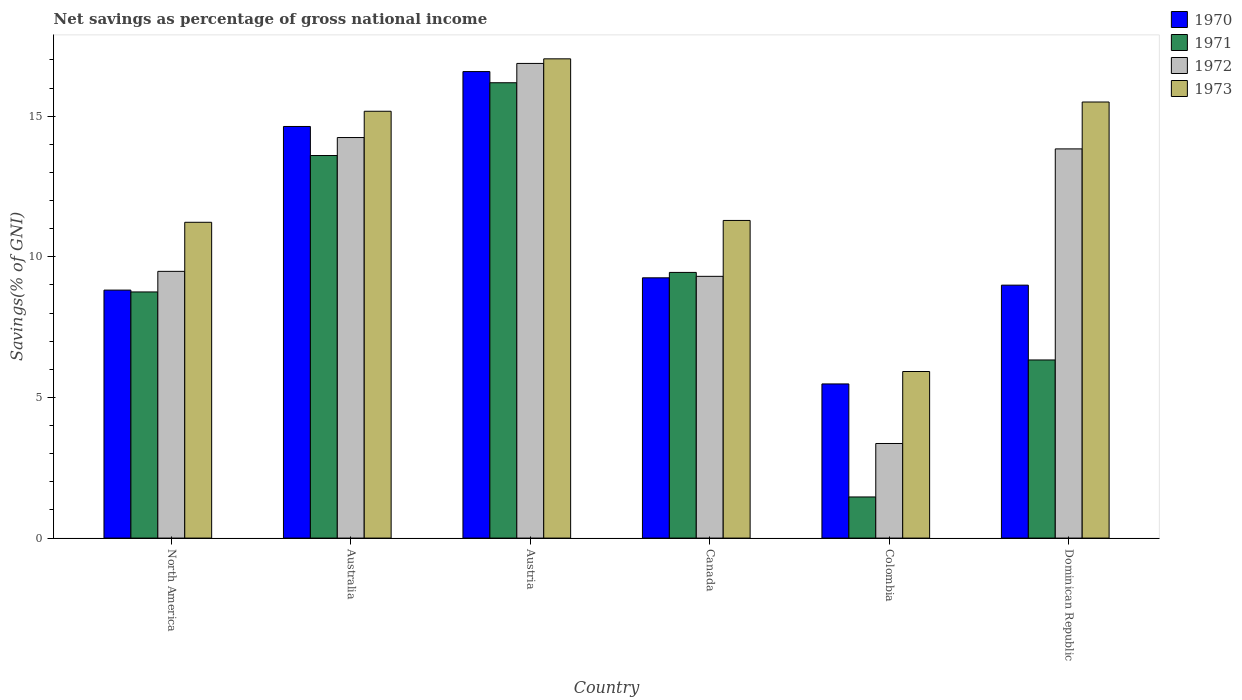How many groups of bars are there?
Offer a terse response. 6. Are the number of bars per tick equal to the number of legend labels?
Provide a short and direct response. Yes. How many bars are there on the 1st tick from the left?
Provide a short and direct response. 4. What is the label of the 3rd group of bars from the left?
Provide a short and direct response. Austria. In how many cases, is the number of bars for a given country not equal to the number of legend labels?
Keep it short and to the point. 0. What is the total savings in 1970 in Austria?
Your answer should be very brief. 16.59. Across all countries, what is the maximum total savings in 1972?
Keep it short and to the point. 16.88. Across all countries, what is the minimum total savings in 1971?
Your response must be concise. 1.46. In which country was the total savings in 1971 minimum?
Keep it short and to the point. Colombia. What is the total total savings in 1973 in the graph?
Your answer should be very brief. 76.17. What is the difference between the total savings in 1973 in Australia and that in Canada?
Offer a very short reply. 3.88. What is the difference between the total savings in 1973 in Austria and the total savings in 1970 in Dominican Republic?
Provide a short and direct response. 8.05. What is the average total savings in 1970 per country?
Ensure brevity in your answer.  10.63. What is the difference between the total savings of/in 1972 and total savings of/in 1973 in Colombia?
Offer a terse response. -2.56. In how many countries, is the total savings in 1972 greater than 12 %?
Your response must be concise. 3. What is the ratio of the total savings in 1973 in Australia to that in Colombia?
Your response must be concise. 2.56. Is the total savings in 1971 in Austria less than that in Colombia?
Your response must be concise. No. Is the difference between the total savings in 1972 in Australia and Canada greater than the difference between the total savings in 1973 in Australia and Canada?
Ensure brevity in your answer.  Yes. What is the difference between the highest and the second highest total savings in 1973?
Offer a terse response. 1.86. What is the difference between the highest and the lowest total savings in 1970?
Give a very brief answer. 11.11. What does the 4th bar from the left in North America represents?
Offer a very short reply. 1973. Is it the case that in every country, the sum of the total savings in 1973 and total savings in 1970 is greater than the total savings in 1971?
Give a very brief answer. Yes. Are all the bars in the graph horizontal?
Ensure brevity in your answer.  No. How many countries are there in the graph?
Ensure brevity in your answer.  6. What is the difference between two consecutive major ticks on the Y-axis?
Give a very brief answer. 5. Does the graph contain any zero values?
Provide a short and direct response. No. How many legend labels are there?
Keep it short and to the point. 4. How are the legend labels stacked?
Make the answer very short. Vertical. What is the title of the graph?
Make the answer very short. Net savings as percentage of gross national income. What is the label or title of the X-axis?
Give a very brief answer. Country. What is the label or title of the Y-axis?
Make the answer very short. Savings(% of GNI). What is the Savings(% of GNI) in 1970 in North America?
Offer a very short reply. 8.82. What is the Savings(% of GNI) in 1971 in North America?
Offer a very short reply. 8.75. What is the Savings(% of GNI) in 1972 in North America?
Provide a succinct answer. 9.48. What is the Savings(% of GNI) in 1973 in North America?
Ensure brevity in your answer.  11.23. What is the Savings(% of GNI) in 1970 in Australia?
Ensure brevity in your answer.  14.63. What is the Savings(% of GNI) of 1971 in Australia?
Offer a terse response. 13.6. What is the Savings(% of GNI) of 1972 in Australia?
Your response must be concise. 14.24. What is the Savings(% of GNI) of 1973 in Australia?
Offer a very short reply. 15.18. What is the Savings(% of GNI) of 1970 in Austria?
Keep it short and to the point. 16.59. What is the Savings(% of GNI) in 1971 in Austria?
Provide a short and direct response. 16.19. What is the Savings(% of GNI) in 1972 in Austria?
Your answer should be compact. 16.88. What is the Savings(% of GNI) of 1973 in Austria?
Offer a very short reply. 17.04. What is the Savings(% of GNI) of 1970 in Canada?
Your answer should be very brief. 9.25. What is the Savings(% of GNI) of 1971 in Canada?
Offer a very short reply. 9.45. What is the Savings(% of GNI) in 1972 in Canada?
Provide a succinct answer. 9.31. What is the Savings(% of GNI) of 1973 in Canada?
Give a very brief answer. 11.29. What is the Savings(% of GNI) in 1970 in Colombia?
Keep it short and to the point. 5.48. What is the Savings(% of GNI) of 1971 in Colombia?
Provide a succinct answer. 1.46. What is the Savings(% of GNI) of 1972 in Colombia?
Give a very brief answer. 3.36. What is the Savings(% of GNI) in 1973 in Colombia?
Give a very brief answer. 5.92. What is the Savings(% of GNI) in 1970 in Dominican Republic?
Keep it short and to the point. 8.99. What is the Savings(% of GNI) of 1971 in Dominican Republic?
Offer a very short reply. 6.33. What is the Savings(% of GNI) of 1972 in Dominican Republic?
Ensure brevity in your answer.  13.84. What is the Savings(% of GNI) in 1973 in Dominican Republic?
Provide a short and direct response. 15.5. Across all countries, what is the maximum Savings(% of GNI) of 1970?
Your answer should be compact. 16.59. Across all countries, what is the maximum Savings(% of GNI) in 1971?
Your answer should be compact. 16.19. Across all countries, what is the maximum Savings(% of GNI) of 1972?
Offer a very short reply. 16.88. Across all countries, what is the maximum Savings(% of GNI) of 1973?
Offer a terse response. 17.04. Across all countries, what is the minimum Savings(% of GNI) of 1970?
Offer a very short reply. 5.48. Across all countries, what is the minimum Savings(% of GNI) in 1971?
Provide a short and direct response. 1.46. Across all countries, what is the minimum Savings(% of GNI) in 1972?
Offer a very short reply. 3.36. Across all countries, what is the minimum Savings(% of GNI) in 1973?
Provide a succinct answer. 5.92. What is the total Savings(% of GNI) of 1970 in the graph?
Make the answer very short. 63.77. What is the total Savings(% of GNI) of 1971 in the graph?
Your response must be concise. 55.79. What is the total Savings(% of GNI) in 1972 in the graph?
Your answer should be compact. 67.11. What is the total Savings(% of GNI) in 1973 in the graph?
Provide a succinct answer. 76.17. What is the difference between the Savings(% of GNI) in 1970 in North America and that in Australia?
Make the answer very short. -5.82. What is the difference between the Savings(% of GNI) of 1971 in North America and that in Australia?
Provide a succinct answer. -4.85. What is the difference between the Savings(% of GNI) of 1972 in North America and that in Australia?
Offer a terse response. -4.76. What is the difference between the Savings(% of GNI) of 1973 in North America and that in Australia?
Provide a succinct answer. -3.95. What is the difference between the Savings(% of GNI) in 1970 in North America and that in Austria?
Your response must be concise. -7.77. What is the difference between the Savings(% of GNI) of 1971 in North America and that in Austria?
Provide a succinct answer. -7.44. What is the difference between the Savings(% of GNI) of 1972 in North America and that in Austria?
Your answer should be very brief. -7.39. What is the difference between the Savings(% of GNI) in 1973 in North America and that in Austria?
Keep it short and to the point. -5.81. What is the difference between the Savings(% of GNI) of 1970 in North America and that in Canada?
Ensure brevity in your answer.  -0.44. What is the difference between the Savings(% of GNI) in 1971 in North America and that in Canada?
Your response must be concise. -0.69. What is the difference between the Savings(% of GNI) in 1972 in North America and that in Canada?
Keep it short and to the point. 0.18. What is the difference between the Savings(% of GNI) of 1973 in North America and that in Canada?
Provide a short and direct response. -0.07. What is the difference between the Savings(% of GNI) of 1970 in North America and that in Colombia?
Give a very brief answer. 3.34. What is the difference between the Savings(% of GNI) in 1971 in North America and that in Colombia?
Ensure brevity in your answer.  7.29. What is the difference between the Savings(% of GNI) of 1972 in North America and that in Colombia?
Provide a short and direct response. 6.12. What is the difference between the Savings(% of GNI) in 1973 in North America and that in Colombia?
Provide a short and direct response. 5.31. What is the difference between the Savings(% of GNI) of 1970 in North America and that in Dominican Republic?
Keep it short and to the point. -0.18. What is the difference between the Savings(% of GNI) of 1971 in North America and that in Dominican Republic?
Make the answer very short. 2.42. What is the difference between the Savings(% of GNI) of 1972 in North America and that in Dominican Republic?
Keep it short and to the point. -4.35. What is the difference between the Savings(% of GNI) in 1973 in North America and that in Dominican Republic?
Offer a very short reply. -4.28. What is the difference between the Savings(% of GNI) in 1970 in Australia and that in Austria?
Offer a terse response. -1.95. What is the difference between the Savings(% of GNI) in 1971 in Australia and that in Austria?
Offer a terse response. -2.59. What is the difference between the Savings(% of GNI) in 1972 in Australia and that in Austria?
Make the answer very short. -2.64. What is the difference between the Savings(% of GNI) of 1973 in Australia and that in Austria?
Your answer should be very brief. -1.86. What is the difference between the Savings(% of GNI) of 1970 in Australia and that in Canada?
Give a very brief answer. 5.38. What is the difference between the Savings(% of GNI) of 1971 in Australia and that in Canada?
Your response must be concise. 4.16. What is the difference between the Savings(% of GNI) in 1972 in Australia and that in Canada?
Offer a terse response. 4.93. What is the difference between the Savings(% of GNI) of 1973 in Australia and that in Canada?
Provide a short and direct response. 3.88. What is the difference between the Savings(% of GNI) in 1970 in Australia and that in Colombia?
Offer a very short reply. 9.15. What is the difference between the Savings(% of GNI) in 1971 in Australia and that in Colombia?
Provide a short and direct response. 12.14. What is the difference between the Savings(% of GNI) of 1972 in Australia and that in Colombia?
Make the answer very short. 10.88. What is the difference between the Savings(% of GNI) in 1973 in Australia and that in Colombia?
Offer a very short reply. 9.25. What is the difference between the Savings(% of GNI) in 1970 in Australia and that in Dominican Republic?
Ensure brevity in your answer.  5.64. What is the difference between the Savings(% of GNI) of 1971 in Australia and that in Dominican Republic?
Keep it short and to the point. 7.27. What is the difference between the Savings(% of GNI) in 1972 in Australia and that in Dominican Republic?
Give a very brief answer. 0.4. What is the difference between the Savings(% of GNI) in 1973 in Australia and that in Dominican Republic?
Ensure brevity in your answer.  -0.33. What is the difference between the Savings(% of GNI) of 1970 in Austria and that in Canada?
Your response must be concise. 7.33. What is the difference between the Savings(% of GNI) of 1971 in Austria and that in Canada?
Ensure brevity in your answer.  6.74. What is the difference between the Savings(% of GNI) of 1972 in Austria and that in Canada?
Your response must be concise. 7.57. What is the difference between the Savings(% of GNI) of 1973 in Austria and that in Canada?
Your response must be concise. 5.75. What is the difference between the Savings(% of GNI) of 1970 in Austria and that in Colombia?
Ensure brevity in your answer.  11.11. What is the difference between the Savings(% of GNI) of 1971 in Austria and that in Colombia?
Provide a succinct answer. 14.73. What is the difference between the Savings(% of GNI) of 1972 in Austria and that in Colombia?
Offer a terse response. 13.51. What is the difference between the Savings(% of GNI) of 1973 in Austria and that in Colombia?
Ensure brevity in your answer.  11.12. What is the difference between the Savings(% of GNI) of 1970 in Austria and that in Dominican Republic?
Offer a terse response. 7.59. What is the difference between the Savings(% of GNI) of 1971 in Austria and that in Dominican Republic?
Keep it short and to the point. 9.86. What is the difference between the Savings(% of GNI) of 1972 in Austria and that in Dominican Republic?
Make the answer very short. 3.04. What is the difference between the Savings(% of GNI) in 1973 in Austria and that in Dominican Republic?
Your answer should be very brief. 1.54. What is the difference between the Savings(% of GNI) in 1970 in Canada and that in Colombia?
Your response must be concise. 3.77. What is the difference between the Savings(% of GNI) in 1971 in Canada and that in Colombia?
Offer a very short reply. 7.98. What is the difference between the Savings(% of GNI) in 1972 in Canada and that in Colombia?
Your answer should be compact. 5.94. What is the difference between the Savings(% of GNI) of 1973 in Canada and that in Colombia?
Make the answer very short. 5.37. What is the difference between the Savings(% of GNI) in 1970 in Canada and that in Dominican Republic?
Offer a very short reply. 0.26. What is the difference between the Savings(% of GNI) of 1971 in Canada and that in Dominican Republic?
Give a very brief answer. 3.11. What is the difference between the Savings(% of GNI) of 1972 in Canada and that in Dominican Republic?
Offer a very short reply. -4.53. What is the difference between the Savings(% of GNI) in 1973 in Canada and that in Dominican Republic?
Your answer should be compact. -4.21. What is the difference between the Savings(% of GNI) in 1970 in Colombia and that in Dominican Republic?
Provide a short and direct response. -3.51. What is the difference between the Savings(% of GNI) of 1971 in Colombia and that in Dominican Republic?
Ensure brevity in your answer.  -4.87. What is the difference between the Savings(% of GNI) of 1972 in Colombia and that in Dominican Republic?
Ensure brevity in your answer.  -10.47. What is the difference between the Savings(% of GNI) in 1973 in Colombia and that in Dominican Republic?
Your answer should be very brief. -9.58. What is the difference between the Savings(% of GNI) in 1970 in North America and the Savings(% of GNI) in 1971 in Australia?
Your response must be concise. -4.78. What is the difference between the Savings(% of GNI) of 1970 in North America and the Savings(% of GNI) of 1972 in Australia?
Make the answer very short. -5.42. What is the difference between the Savings(% of GNI) in 1970 in North America and the Savings(% of GNI) in 1973 in Australia?
Provide a succinct answer. -6.36. What is the difference between the Savings(% of GNI) in 1971 in North America and the Savings(% of GNI) in 1972 in Australia?
Provide a succinct answer. -5.49. What is the difference between the Savings(% of GNI) in 1971 in North America and the Savings(% of GNI) in 1973 in Australia?
Provide a succinct answer. -6.42. What is the difference between the Savings(% of GNI) of 1972 in North America and the Savings(% of GNI) of 1973 in Australia?
Your answer should be very brief. -5.69. What is the difference between the Savings(% of GNI) in 1970 in North America and the Savings(% of GNI) in 1971 in Austria?
Your response must be concise. -7.37. What is the difference between the Savings(% of GNI) of 1970 in North America and the Savings(% of GNI) of 1972 in Austria?
Your answer should be very brief. -8.06. What is the difference between the Savings(% of GNI) of 1970 in North America and the Savings(% of GNI) of 1973 in Austria?
Make the answer very short. -8.22. What is the difference between the Savings(% of GNI) of 1971 in North America and the Savings(% of GNI) of 1972 in Austria?
Your answer should be very brief. -8.12. What is the difference between the Savings(% of GNI) of 1971 in North America and the Savings(% of GNI) of 1973 in Austria?
Keep it short and to the point. -8.29. What is the difference between the Savings(% of GNI) of 1972 in North America and the Savings(% of GNI) of 1973 in Austria?
Provide a short and direct response. -7.56. What is the difference between the Savings(% of GNI) in 1970 in North America and the Savings(% of GNI) in 1971 in Canada?
Provide a short and direct response. -0.63. What is the difference between the Savings(% of GNI) of 1970 in North America and the Savings(% of GNI) of 1972 in Canada?
Offer a very short reply. -0.49. What is the difference between the Savings(% of GNI) of 1970 in North America and the Savings(% of GNI) of 1973 in Canada?
Your answer should be compact. -2.48. What is the difference between the Savings(% of GNI) in 1971 in North America and the Savings(% of GNI) in 1972 in Canada?
Your response must be concise. -0.55. What is the difference between the Savings(% of GNI) of 1971 in North America and the Savings(% of GNI) of 1973 in Canada?
Your answer should be very brief. -2.54. What is the difference between the Savings(% of GNI) in 1972 in North America and the Savings(% of GNI) in 1973 in Canada?
Make the answer very short. -1.81. What is the difference between the Savings(% of GNI) in 1970 in North America and the Savings(% of GNI) in 1971 in Colombia?
Your answer should be very brief. 7.36. What is the difference between the Savings(% of GNI) in 1970 in North America and the Savings(% of GNI) in 1972 in Colombia?
Your answer should be compact. 5.45. What is the difference between the Savings(% of GNI) in 1970 in North America and the Savings(% of GNI) in 1973 in Colombia?
Your response must be concise. 2.89. What is the difference between the Savings(% of GNI) of 1971 in North America and the Savings(% of GNI) of 1972 in Colombia?
Offer a very short reply. 5.39. What is the difference between the Savings(% of GNI) in 1971 in North America and the Savings(% of GNI) in 1973 in Colombia?
Make the answer very short. 2.83. What is the difference between the Savings(% of GNI) of 1972 in North America and the Savings(% of GNI) of 1973 in Colombia?
Your answer should be compact. 3.56. What is the difference between the Savings(% of GNI) of 1970 in North America and the Savings(% of GNI) of 1971 in Dominican Republic?
Your answer should be very brief. 2.48. What is the difference between the Savings(% of GNI) in 1970 in North America and the Savings(% of GNI) in 1972 in Dominican Republic?
Your answer should be compact. -5.02. What is the difference between the Savings(% of GNI) in 1970 in North America and the Savings(% of GNI) in 1973 in Dominican Republic?
Your response must be concise. -6.69. What is the difference between the Savings(% of GNI) in 1971 in North America and the Savings(% of GNI) in 1972 in Dominican Republic?
Your response must be concise. -5.09. What is the difference between the Savings(% of GNI) in 1971 in North America and the Savings(% of GNI) in 1973 in Dominican Republic?
Give a very brief answer. -6.75. What is the difference between the Savings(% of GNI) of 1972 in North America and the Savings(% of GNI) of 1973 in Dominican Republic?
Provide a succinct answer. -6.02. What is the difference between the Savings(% of GNI) of 1970 in Australia and the Savings(% of GNI) of 1971 in Austria?
Offer a very short reply. -1.55. What is the difference between the Savings(% of GNI) of 1970 in Australia and the Savings(% of GNI) of 1972 in Austria?
Give a very brief answer. -2.24. What is the difference between the Savings(% of GNI) in 1970 in Australia and the Savings(% of GNI) in 1973 in Austria?
Offer a terse response. -2.4. What is the difference between the Savings(% of GNI) of 1971 in Australia and the Savings(% of GNI) of 1972 in Austria?
Offer a terse response. -3.27. What is the difference between the Savings(% of GNI) in 1971 in Australia and the Savings(% of GNI) in 1973 in Austria?
Make the answer very short. -3.44. What is the difference between the Savings(% of GNI) in 1972 in Australia and the Savings(% of GNI) in 1973 in Austria?
Your response must be concise. -2.8. What is the difference between the Savings(% of GNI) in 1970 in Australia and the Savings(% of GNI) in 1971 in Canada?
Offer a terse response. 5.19. What is the difference between the Savings(% of GNI) of 1970 in Australia and the Savings(% of GNI) of 1972 in Canada?
Give a very brief answer. 5.33. What is the difference between the Savings(% of GNI) in 1970 in Australia and the Savings(% of GNI) in 1973 in Canada?
Your answer should be very brief. 3.34. What is the difference between the Savings(% of GNI) of 1971 in Australia and the Savings(% of GNI) of 1972 in Canada?
Provide a succinct answer. 4.3. What is the difference between the Savings(% of GNI) in 1971 in Australia and the Savings(% of GNI) in 1973 in Canada?
Offer a terse response. 2.31. What is the difference between the Savings(% of GNI) of 1972 in Australia and the Savings(% of GNI) of 1973 in Canada?
Provide a short and direct response. 2.95. What is the difference between the Savings(% of GNI) in 1970 in Australia and the Savings(% of GNI) in 1971 in Colombia?
Provide a succinct answer. 13.17. What is the difference between the Savings(% of GNI) in 1970 in Australia and the Savings(% of GNI) in 1972 in Colombia?
Give a very brief answer. 11.27. What is the difference between the Savings(% of GNI) of 1970 in Australia and the Savings(% of GNI) of 1973 in Colombia?
Give a very brief answer. 8.71. What is the difference between the Savings(% of GNI) of 1971 in Australia and the Savings(% of GNI) of 1972 in Colombia?
Ensure brevity in your answer.  10.24. What is the difference between the Savings(% of GNI) of 1971 in Australia and the Savings(% of GNI) of 1973 in Colombia?
Provide a succinct answer. 7.68. What is the difference between the Savings(% of GNI) of 1972 in Australia and the Savings(% of GNI) of 1973 in Colombia?
Offer a very short reply. 8.32. What is the difference between the Savings(% of GNI) in 1970 in Australia and the Savings(% of GNI) in 1971 in Dominican Republic?
Keep it short and to the point. 8.3. What is the difference between the Savings(% of GNI) of 1970 in Australia and the Savings(% of GNI) of 1972 in Dominican Republic?
Give a very brief answer. 0.8. What is the difference between the Savings(% of GNI) in 1970 in Australia and the Savings(% of GNI) in 1973 in Dominican Republic?
Give a very brief answer. -0.87. What is the difference between the Savings(% of GNI) in 1971 in Australia and the Savings(% of GNI) in 1972 in Dominican Republic?
Your answer should be compact. -0.24. What is the difference between the Savings(% of GNI) in 1971 in Australia and the Savings(% of GNI) in 1973 in Dominican Republic?
Make the answer very short. -1.9. What is the difference between the Savings(% of GNI) of 1972 in Australia and the Savings(% of GNI) of 1973 in Dominican Republic?
Keep it short and to the point. -1.26. What is the difference between the Savings(% of GNI) in 1970 in Austria and the Savings(% of GNI) in 1971 in Canada?
Ensure brevity in your answer.  7.14. What is the difference between the Savings(% of GNI) in 1970 in Austria and the Savings(% of GNI) in 1972 in Canada?
Offer a terse response. 7.28. What is the difference between the Savings(% of GNI) in 1970 in Austria and the Savings(% of GNI) in 1973 in Canada?
Offer a very short reply. 5.29. What is the difference between the Savings(% of GNI) in 1971 in Austria and the Savings(% of GNI) in 1972 in Canada?
Provide a short and direct response. 6.88. What is the difference between the Savings(% of GNI) of 1971 in Austria and the Savings(% of GNI) of 1973 in Canada?
Your answer should be very brief. 4.9. What is the difference between the Savings(% of GNI) in 1972 in Austria and the Savings(% of GNI) in 1973 in Canada?
Give a very brief answer. 5.58. What is the difference between the Savings(% of GNI) of 1970 in Austria and the Savings(% of GNI) of 1971 in Colombia?
Ensure brevity in your answer.  15.12. What is the difference between the Savings(% of GNI) in 1970 in Austria and the Savings(% of GNI) in 1972 in Colombia?
Your answer should be very brief. 13.22. What is the difference between the Savings(% of GNI) in 1970 in Austria and the Savings(% of GNI) in 1973 in Colombia?
Your response must be concise. 10.66. What is the difference between the Savings(% of GNI) in 1971 in Austria and the Savings(% of GNI) in 1972 in Colombia?
Offer a terse response. 12.83. What is the difference between the Savings(% of GNI) of 1971 in Austria and the Savings(% of GNI) of 1973 in Colombia?
Give a very brief answer. 10.27. What is the difference between the Savings(% of GNI) in 1972 in Austria and the Savings(% of GNI) in 1973 in Colombia?
Your answer should be very brief. 10.95. What is the difference between the Savings(% of GNI) of 1970 in Austria and the Savings(% of GNI) of 1971 in Dominican Republic?
Provide a succinct answer. 10.25. What is the difference between the Savings(% of GNI) in 1970 in Austria and the Savings(% of GNI) in 1972 in Dominican Republic?
Offer a very short reply. 2.75. What is the difference between the Savings(% of GNI) of 1970 in Austria and the Savings(% of GNI) of 1973 in Dominican Republic?
Your response must be concise. 1.08. What is the difference between the Savings(% of GNI) in 1971 in Austria and the Savings(% of GNI) in 1972 in Dominican Republic?
Offer a very short reply. 2.35. What is the difference between the Savings(% of GNI) of 1971 in Austria and the Savings(% of GNI) of 1973 in Dominican Republic?
Offer a terse response. 0.69. What is the difference between the Savings(% of GNI) of 1972 in Austria and the Savings(% of GNI) of 1973 in Dominican Republic?
Offer a very short reply. 1.37. What is the difference between the Savings(% of GNI) in 1970 in Canada and the Savings(% of GNI) in 1971 in Colombia?
Your answer should be compact. 7.79. What is the difference between the Savings(% of GNI) of 1970 in Canada and the Savings(% of GNI) of 1972 in Colombia?
Make the answer very short. 5.89. What is the difference between the Savings(% of GNI) of 1970 in Canada and the Savings(% of GNI) of 1973 in Colombia?
Your response must be concise. 3.33. What is the difference between the Savings(% of GNI) of 1971 in Canada and the Savings(% of GNI) of 1972 in Colombia?
Keep it short and to the point. 6.08. What is the difference between the Savings(% of GNI) of 1971 in Canada and the Savings(% of GNI) of 1973 in Colombia?
Offer a very short reply. 3.52. What is the difference between the Savings(% of GNI) of 1972 in Canada and the Savings(% of GNI) of 1973 in Colombia?
Provide a succinct answer. 3.38. What is the difference between the Savings(% of GNI) in 1970 in Canada and the Savings(% of GNI) in 1971 in Dominican Republic?
Offer a terse response. 2.92. What is the difference between the Savings(% of GNI) in 1970 in Canada and the Savings(% of GNI) in 1972 in Dominican Republic?
Provide a short and direct response. -4.58. What is the difference between the Savings(% of GNI) in 1970 in Canada and the Savings(% of GNI) in 1973 in Dominican Republic?
Give a very brief answer. -6.25. What is the difference between the Savings(% of GNI) of 1971 in Canada and the Savings(% of GNI) of 1972 in Dominican Republic?
Your answer should be compact. -4.39. What is the difference between the Savings(% of GNI) of 1971 in Canada and the Savings(% of GNI) of 1973 in Dominican Republic?
Your response must be concise. -6.06. What is the difference between the Savings(% of GNI) of 1972 in Canada and the Savings(% of GNI) of 1973 in Dominican Republic?
Offer a very short reply. -6.2. What is the difference between the Savings(% of GNI) of 1970 in Colombia and the Savings(% of GNI) of 1971 in Dominican Republic?
Your answer should be very brief. -0.85. What is the difference between the Savings(% of GNI) of 1970 in Colombia and the Savings(% of GNI) of 1972 in Dominican Republic?
Provide a succinct answer. -8.36. What is the difference between the Savings(% of GNI) of 1970 in Colombia and the Savings(% of GNI) of 1973 in Dominican Republic?
Ensure brevity in your answer.  -10.02. What is the difference between the Savings(% of GNI) in 1971 in Colombia and the Savings(% of GNI) in 1972 in Dominican Republic?
Keep it short and to the point. -12.38. What is the difference between the Savings(% of GNI) in 1971 in Colombia and the Savings(% of GNI) in 1973 in Dominican Republic?
Make the answer very short. -14.04. What is the difference between the Savings(% of GNI) in 1972 in Colombia and the Savings(% of GNI) in 1973 in Dominican Republic?
Keep it short and to the point. -12.14. What is the average Savings(% of GNI) of 1970 per country?
Make the answer very short. 10.63. What is the average Savings(% of GNI) of 1971 per country?
Give a very brief answer. 9.3. What is the average Savings(% of GNI) in 1972 per country?
Your answer should be very brief. 11.19. What is the average Savings(% of GNI) in 1973 per country?
Your answer should be compact. 12.69. What is the difference between the Savings(% of GNI) in 1970 and Savings(% of GNI) in 1971 in North America?
Your response must be concise. 0.07. What is the difference between the Savings(% of GNI) of 1970 and Savings(% of GNI) of 1972 in North America?
Give a very brief answer. -0.67. What is the difference between the Savings(% of GNI) in 1970 and Savings(% of GNI) in 1973 in North America?
Give a very brief answer. -2.41. What is the difference between the Savings(% of GNI) of 1971 and Savings(% of GNI) of 1972 in North America?
Make the answer very short. -0.73. What is the difference between the Savings(% of GNI) of 1971 and Savings(% of GNI) of 1973 in North America?
Keep it short and to the point. -2.48. What is the difference between the Savings(% of GNI) of 1972 and Savings(% of GNI) of 1973 in North America?
Provide a succinct answer. -1.74. What is the difference between the Savings(% of GNI) of 1970 and Savings(% of GNI) of 1971 in Australia?
Ensure brevity in your answer.  1.03. What is the difference between the Savings(% of GNI) in 1970 and Savings(% of GNI) in 1972 in Australia?
Provide a short and direct response. 0.39. What is the difference between the Savings(% of GNI) in 1970 and Savings(% of GNI) in 1973 in Australia?
Your answer should be very brief. -0.54. What is the difference between the Savings(% of GNI) of 1971 and Savings(% of GNI) of 1972 in Australia?
Ensure brevity in your answer.  -0.64. What is the difference between the Savings(% of GNI) of 1971 and Savings(% of GNI) of 1973 in Australia?
Your response must be concise. -1.57. What is the difference between the Savings(% of GNI) of 1972 and Savings(% of GNI) of 1973 in Australia?
Ensure brevity in your answer.  -0.93. What is the difference between the Savings(% of GNI) of 1970 and Savings(% of GNI) of 1971 in Austria?
Give a very brief answer. 0.4. What is the difference between the Savings(% of GNI) in 1970 and Savings(% of GNI) in 1972 in Austria?
Your answer should be compact. -0.29. What is the difference between the Savings(% of GNI) in 1970 and Savings(% of GNI) in 1973 in Austria?
Provide a short and direct response. -0.45. What is the difference between the Savings(% of GNI) in 1971 and Savings(% of GNI) in 1972 in Austria?
Give a very brief answer. -0.69. What is the difference between the Savings(% of GNI) in 1971 and Savings(% of GNI) in 1973 in Austria?
Your answer should be very brief. -0.85. What is the difference between the Savings(% of GNI) of 1972 and Savings(% of GNI) of 1973 in Austria?
Your response must be concise. -0.16. What is the difference between the Savings(% of GNI) of 1970 and Savings(% of GNI) of 1971 in Canada?
Make the answer very short. -0.19. What is the difference between the Savings(% of GNI) in 1970 and Savings(% of GNI) in 1972 in Canada?
Offer a terse response. -0.05. What is the difference between the Savings(% of GNI) of 1970 and Savings(% of GNI) of 1973 in Canada?
Your answer should be very brief. -2.04. What is the difference between the Savings(% of GNI) in 1971 and Savings(% of GNI) in 1972 in Canada?
Give a very brief answer. 0.14. What is the difference between the Savings(% of GNI) in 1971 and Savings(% of GNI) in 1973 in Canada?
Your answer should be compact. -1.85. What is the difference between the Savings(% of GNI) in 1972 and Savings(% of GNI) in 1973 in Canada?
Give a very brief answer. -1.99. What is the difference between the Savings(% of GNI) in 1970 and Savings(% of GNI) in 1971 in Colombia?
Provide a succinct answer. 4.02. What is the difference between the Savings(% of GNI) in 1970 and Savings(% of GNI) in 1972 in Colombia?
Your answer should be compact. 2.12. What is the difference between the Savings(% of GNI) of 1970 and Savings(% of GNI) of 1973 in Colombia?
Offer a terse response. -0.44. What is the difference between the Savings(% of GNI) in 1971 and Savings(% of GNI) in 1972 in Colombia?
Keep it short and to the point. -1.9. What is the difference between the Savings(% of GNI) in 1971 and Savings(% of GNI) in 1973 in Colombia?
Provide a succinct answer. -4.46. What is the difference between the Savings(% of GNI) in 1972 and Savings(% of GNI) in 1973 in Colombia?
Give a very brief answer. -2.56. What is the difference between the Savings(% of GNI) in 1970 and Savings(% of GNI) in 1971 in Dominican Republic?
Provide a short and direct response. 2.66. What is the difference between the Savings(% of GNI) in 1970 and Savings(% of GNI) in 1972 in Dominican Republic?
Ensure brevity in your answer.  -4.84. What is the difference between the Savings(% of GNI) in 1970 and Savings(% of GNI) in 1973 in Dominican Republic?
Provide a short and direct response. -6.51. What is the difference between the Savings(% of GNI) in 1971 and Savings(% of GNI) in 1972 in Dominican Republic?
Your answer should be compact. -7.5. What is the difference between the Savings(% of GNI) of 1971 and Savings(% of GNI) of 1973 in Dominican Republic?
Your answer should be compact. -9.17. What is the difference between the Savings(% of GNI) of 1972 and Savings(% of GNI) of 1973 in Dominican Republic?
Provide a succinct answer. -1.67. What is the ratio of the Savings(% of GNI) of 1970 in North America to that in Australia?
Ensure brevity in your answer.  0.6. What is the ratio of the Savings(% of GNI) of 1971 in North America to that in Australia?
Your answer should be compact. 0.64. What is the ratio of the Savings(% of GNI) in 1972 in North America to that in Australia?
Provide a short and direct response. 0.67. What is the ratio of the Savings(% of GNI) of 1973 in North America to that in Australia?
Ensure brevity in your answer.  0.74. What is the ratio of the Savings(% of GNI) of 1970 in North America to that in Austria?
Your answer should be compact. 0.53. What is the ratio of the Savings(% of GNI) of 1971 in North America to that in Austria?
Give a very brief answer. 0.54. What is the ratio of the Savings(% of GNI) of 1972 in North America to that in Austria?
Keep it short and to the point. 0.56. What is the ratio of the Savings(% of GNI) of 1973 in North America to that in Austria?
Keep it short and to the point. 0.66. What is the ratio of the Savings(% of GNI) of 1970 in North America to that in Canada?
Your response must be concise. 0.95. What is the ratio of the Savings(% of GNI) of 1971 in North America to that in Canada?
Provide a succinct answer. 0.93. What is the ratio of the Savings(% of GNI) of 1972 in North America to that in Canada?
Your response must be concise. 1.02. What is the ratio of the Savings(% of GNI) in 1970 in North America to that in Colombia?
Make the answer very short. 1.61. What is the ratio of the Savings(% of GNI) of 1971 in North America to that in Colombia?
Keep it short and to the point. 5.98. What is the ratio of the Savings(% of GNI) in 1972 in North America to that in Colombia?
Your answer should be very brief. 2.82. What is the ratio of the Savings(% of GNI) of 1973 in North America to that in Colombia?
Provide a short and direct response. 1.9. What is the ratio of the Savings(% of GNI) in 1970 in North America to that in Dominican Republic?
Offer a terse response. 0.98. What is the ratio of the Savings(% of GNI) of 1971 in North America to that in Dominican Republic?
Give a very brief answer. 1.38. What is the ratio of the Savings(% of GNI) of 1972 in North America to that in Dominican Republic?
Make the answer very short. 0.69. What is the ratio of the Savings(% of GNI) in 1973 in North America to that in Dominican Republic?
Offer a terse response. 0.72. What is the ratio of the Savings(% of GNI) of 1970 in Australia to that in Austria?
Provide a succinct answer. 0.88. What is the ratio of the Savings(% of GNI) of 1971 in Australia to that in Austria?
Provide a succinct answer. 0.84. What is the ratio of the Savings(% of GNI) of 1972 in Australia to that in Austria?
Offer a terse response. 0.84. What is the ratio of the Savings(% of GNI) of 1973 in Australia to that in Austria?
Keep it short and to the point. 0.89. What is the ratio of the Savings(% of GNI) in 1970 in Australia to that in Canada?
Your answer should be compact. 1.58. What is the ratio of the Savings(% of GNI) of 1971 in Australia to that in Canada?
Your response must be concise. 1.44. What is the ratio of the Savings(% of GNI) of 1972 in Australia to that in Canada?
Offer a terse response. 1.53. What is the ratio of the Savings(% of GNI) in 1973 in Australia to that in Canada?
Make the answer very short. 1.34. What is the ratio of the Savings(% of GNI) of 1970 in Australia to that in Colombia?
Give a very brief answer. 2.67. What is the ratio of the Savings(% of GNI) in 1971 in Australia to that in Colombia?
Offer a very short reply. 9.3. What is the ratio of the Savings(% of GNI) of 1972 in Australia to that in Colombia?
Your response must be concise. 4.23. What is the ratio of the Savings(% of GNI) in 1973 in Australia to that in Colombia?
Offer a very short reply. 2.56. What is the ratio of the Savings(% of GNI) of 1970 in Australia to that in Dominican Republic?
Offer a terse response. 1.63. What is the ratio of the Savings(% of GNI) of 1971 in Australia to that in Dominican Republic?
Give a very brief answer. 2.15. What is the ratio of the Savings(% of GNI) of 1972 in Australia to that in Dominican Republic?
Offer a very short reply. 1.03. What is the ratio of the Savings(% of GNI) of 1973 in Australia to that in Dominican Republic?
Make the answer very short. 0.98. What is the ratio of the Savings(% of GNI) in 1970 in Austria to that in Canada?
Offer a terse response. 1.79. What is the ratio of the Savings(% of GNI) in 1971 in Austria to that in Canada?
Ensure brevity in your answer.  1.71. What is the ratio of the Savings(% of GNI) in 1972 in Austria to that in Canada?
Your answer should be very brief. 1.81. What is the ratio of the Savings(% of GNI) in 1973 in Austria to that in Canada?
Provide a short and direct response. 1.51. What is the ratio of the Savings(% of GNI) of 1970 in Austria to that in Colombia?
Provide a short and direct response. 3.03. What is the ratio of the Savings(% of GNI) of 1971 in Austria to that in Colombia?
Offer a very short reply. 11.07. What is the ratio of the Savings(% of GNI) of 1972 in Austria to that in Colombia?
Provide a short and direct response. 5.02. What is the ratio of the Savings(% of GNI) of 1973 in Austria to that in Colombia?
Your answer should be compact. 2.88. What is the ratio of the Savings(% of GNI) in 1970 in Austria to that in Dominican Republic?
Your answer should be compact. 1.84. What is the ratio of the Savings(% of GNI) of 1971 in Austria to that in Dominican Republic?
Provide a short and direct response. 2.56. What is the ratio of the Savings(% of GNI) in 1972 in Austria to that in Dominican Republic?
Ensure brevity in your answer.  1.22. What is the ratio of the Savings(% of GNI) of 1973 in Austria to that in Dominican Republic?
Give a very brief answer. 1.1. What is the ratio of the Savings(% of GNI) of 1970 in Canada to that in Colombia?
Keep it short and to the point. 1.69. What is the ratio of the Savings(% of GNI) of 1971 in Canada to that in Colombia?
Give a very brief answer. 6.46. What is the ratio of the Savings(% of GNI) in 1972 in Canada to that in Colombia?
Make the answer very short. 2.77. What is the ratio of the Savings(% of GNI) in 1973 in Canada to that in Colombia?
Your answer should be very brief. 1.91. What is the ratio of the Savings(% of GNI) in 1971 in Canada to that in Dominican Republic?
Keep it short and to the point. 1.49. What is the ratio of the Savings(% of GNI) in 1972 in Canada to that in Dominican Republic?
Your answer should be compact. 0.67. What is the ratio of the Savings(% of GNI) of 1973 in Canada to that in Dominican Republic?
Your answer should be very brief. 0.73. What is the ratio of the Savings(% of GNI) of 1970 in Colombia to that in Dominican Republic?
Provide a succinct answer. 0.61. What is the ratio of the Savings(% of GNI) of 1971 in Colombia to that in Dominican Republic?
Ensure brevity in your answer.  0.23. What is the ratio of the Savings(% of GNI) in 1972 in Colombia to that in Dominican Republic?
Offer a very short reply. 0.24. What is the ratio of the Savings(% of GNI) in 1973 in Colombia to that in Dominican Republic?
Your response must be concise. 0.38. What is the difference between the highest and the second highest Savings(% of GNI) in 1970?
Keep it short and to the point. 1.95. What is the difference between the highest and the second highest Savings(% of GNI) in 1971?
Offer a very short reply. 2.59. What is the difference between the highest and the second highest Savings(% of GNI) of 1972?
Make the answer very short. 2.64. What is the difference between the highest and the second highest Savings(% of GNI) in 1973?
Provide a succinct answer. 1.54. What is the difference between the highest and the lowest Savings(% of GNI) in 1970?
Offer a very short reply. 11.11. What is the difference between the highest and the lowest Savings(% of GNI) of 1971?
Keep it short and to the point. 14.73. What is the difference between the highest and the lowest Savings(% of GNI) in 1972?
Your response must be concise. 13.51. What is the difference between the highest and the lowest Savings(% of GNI) in 1973?
Your response must be concise. 11.12. 